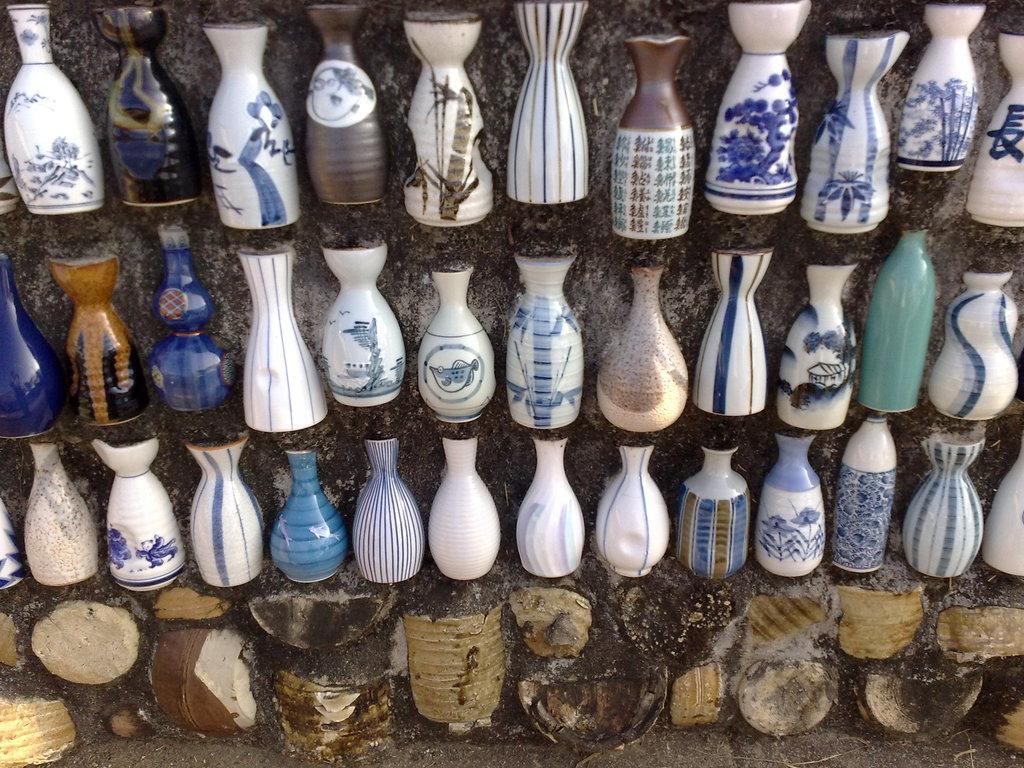In one or two sentences, can you explain what this image depicts? Here we can see vases. In the background there is a wall. 